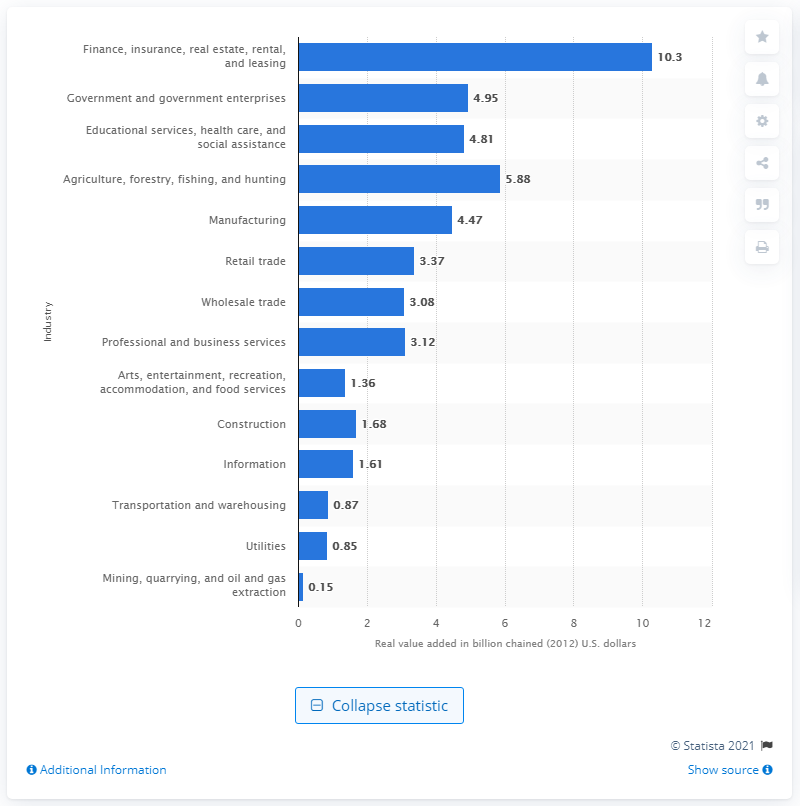Give some essential details in this illustration. In 2020, the finance, insurance, real estate, rental, and leasing industry contributed $10.3 billion to the total gross domestic product (GDP) of South Dakota. 